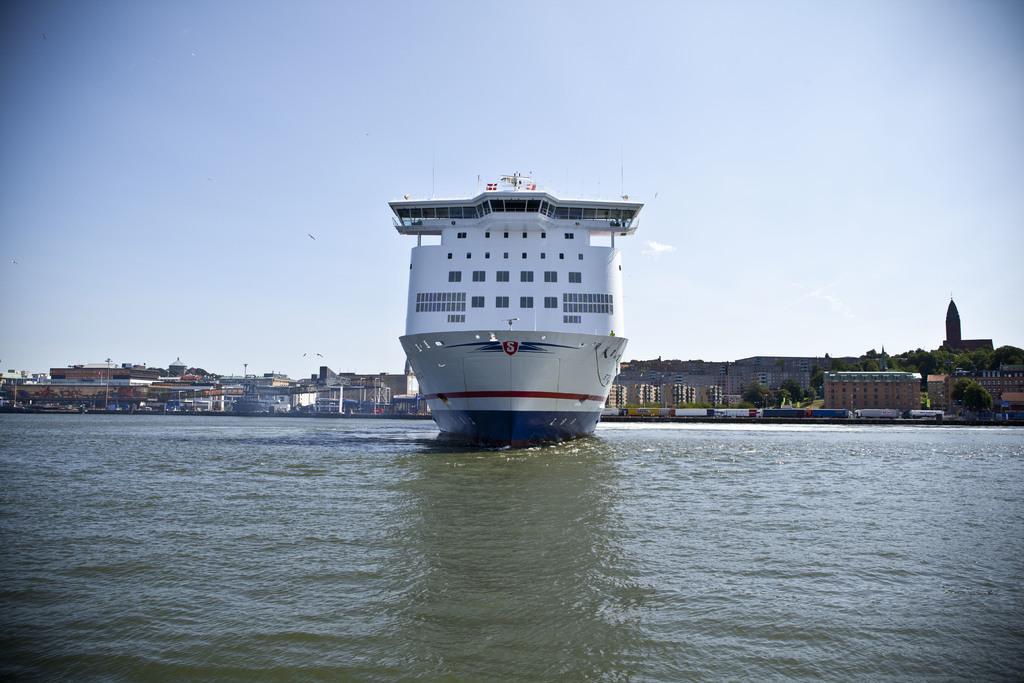In one or two sentences, can you explain what this image depicts? In this image there is a ship in the water. In the background there are so many buildings one beside the other. At the top there is the sky. At the bottom there is water. There are rooms in the ship. 